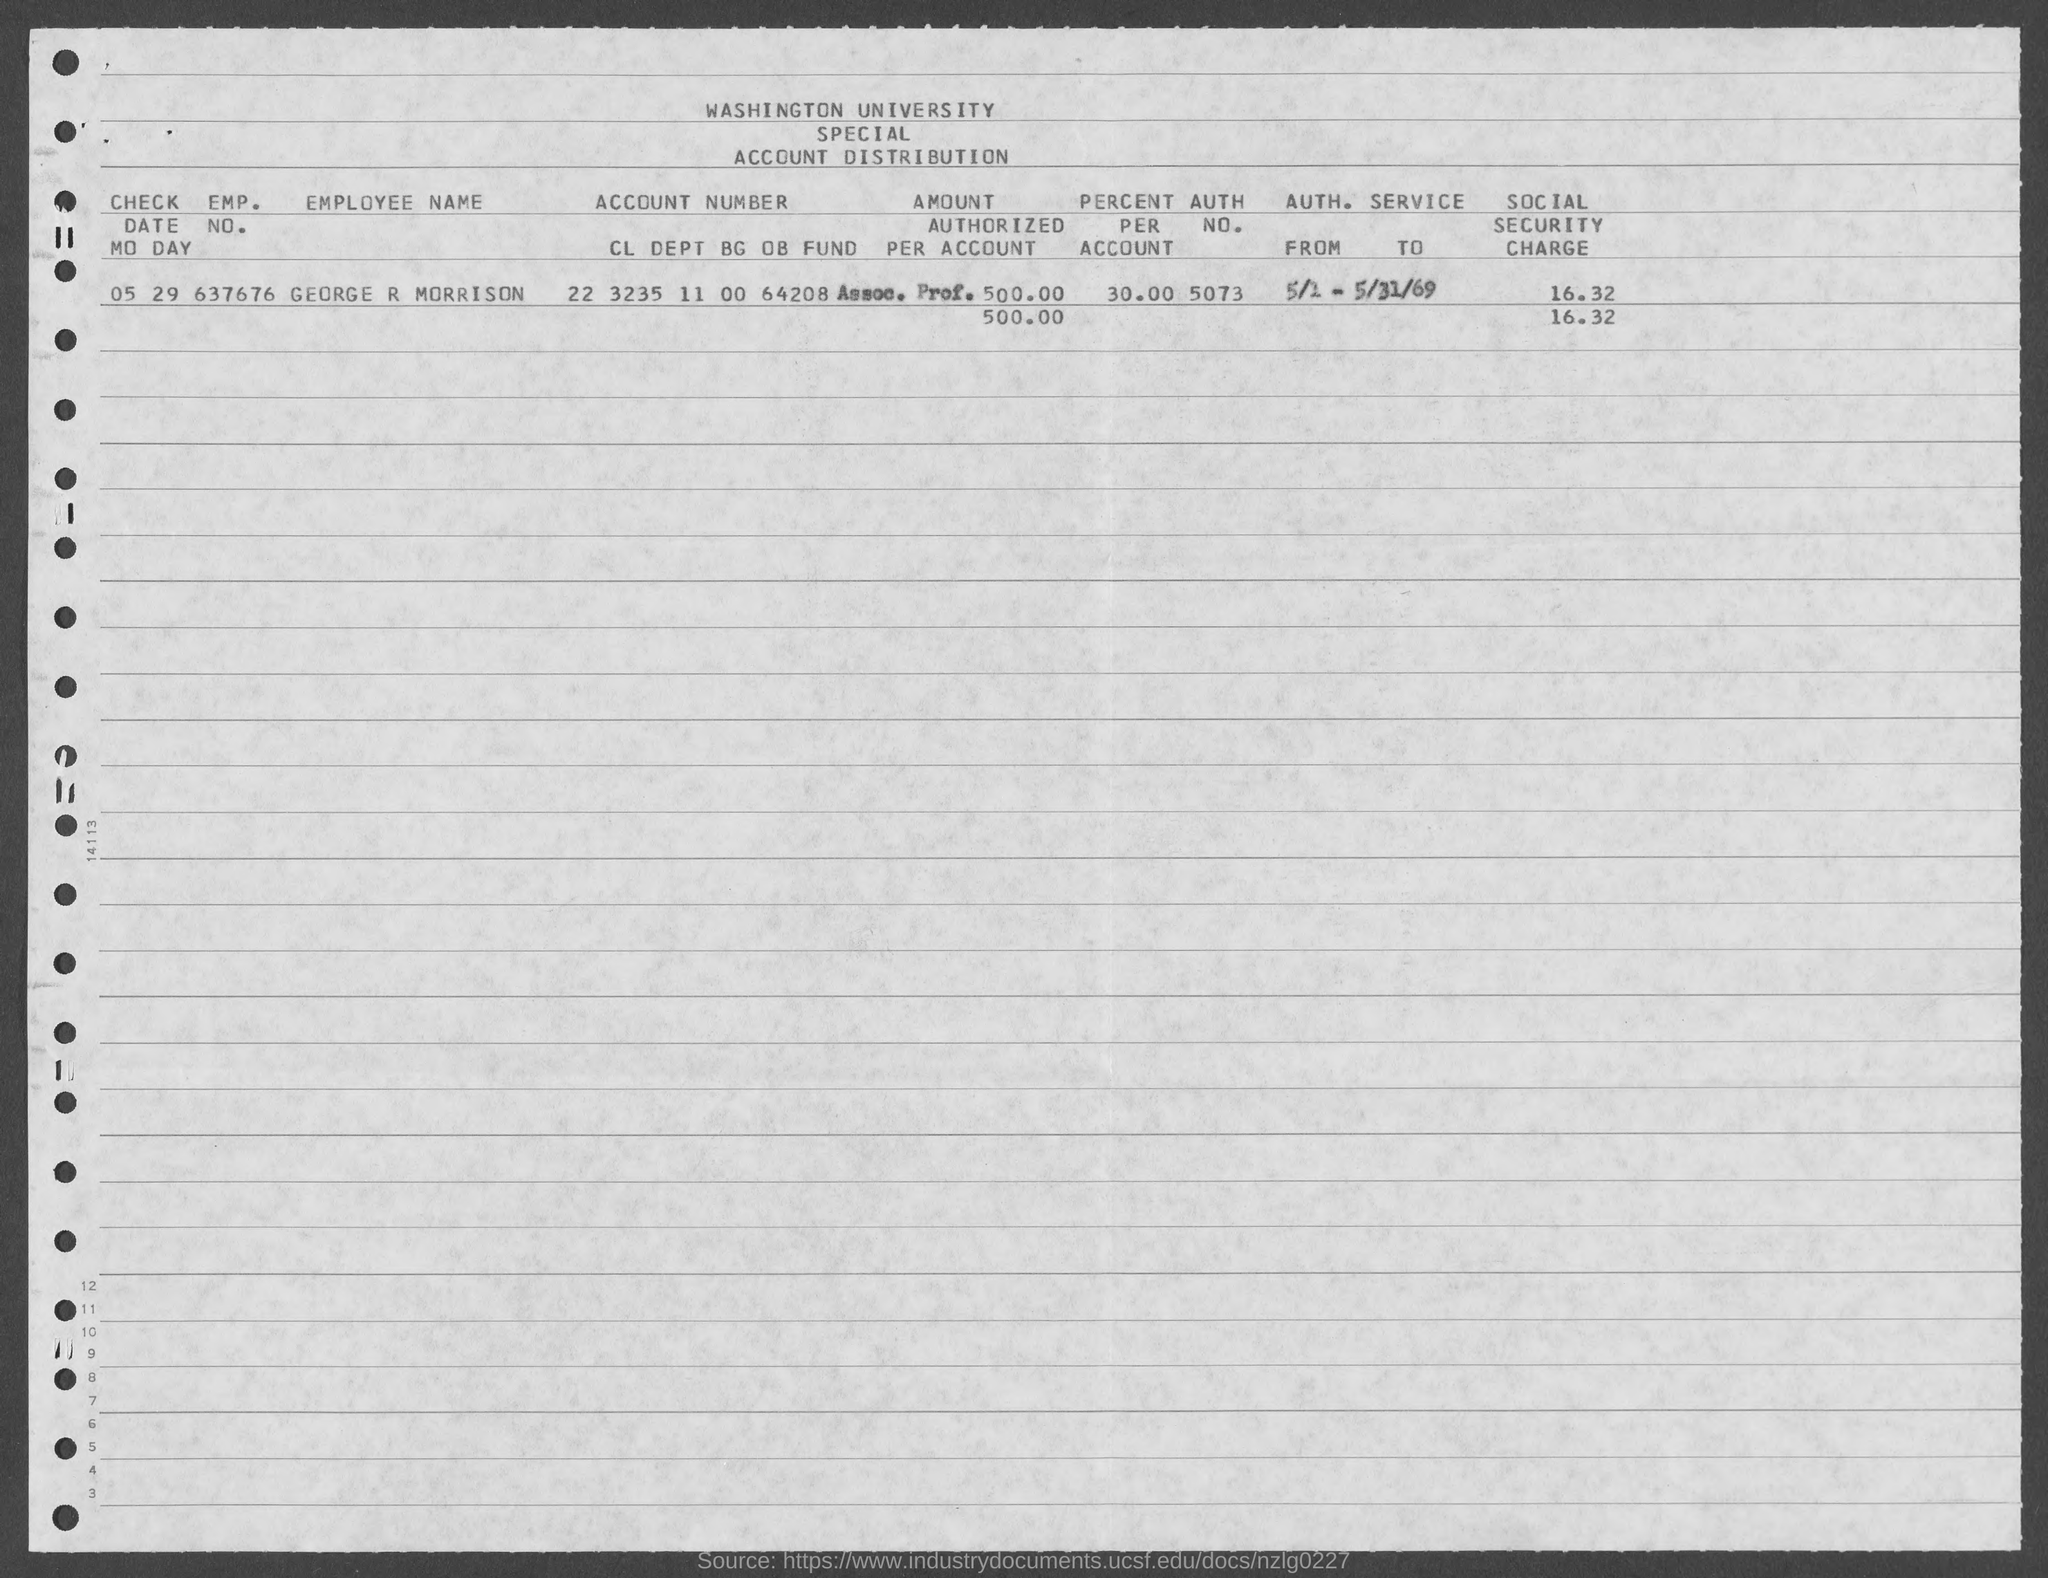What is the Emp. No. ?
Offer a terse response. 637676. What is the Employee Name ?
Your answer should be very brief. GEORGE R MORRISON. What is the Percentage Per Account ?
Make the answer very short. 30. What is the Social Security Charge ?
Give a very brief answer. 16.32. 